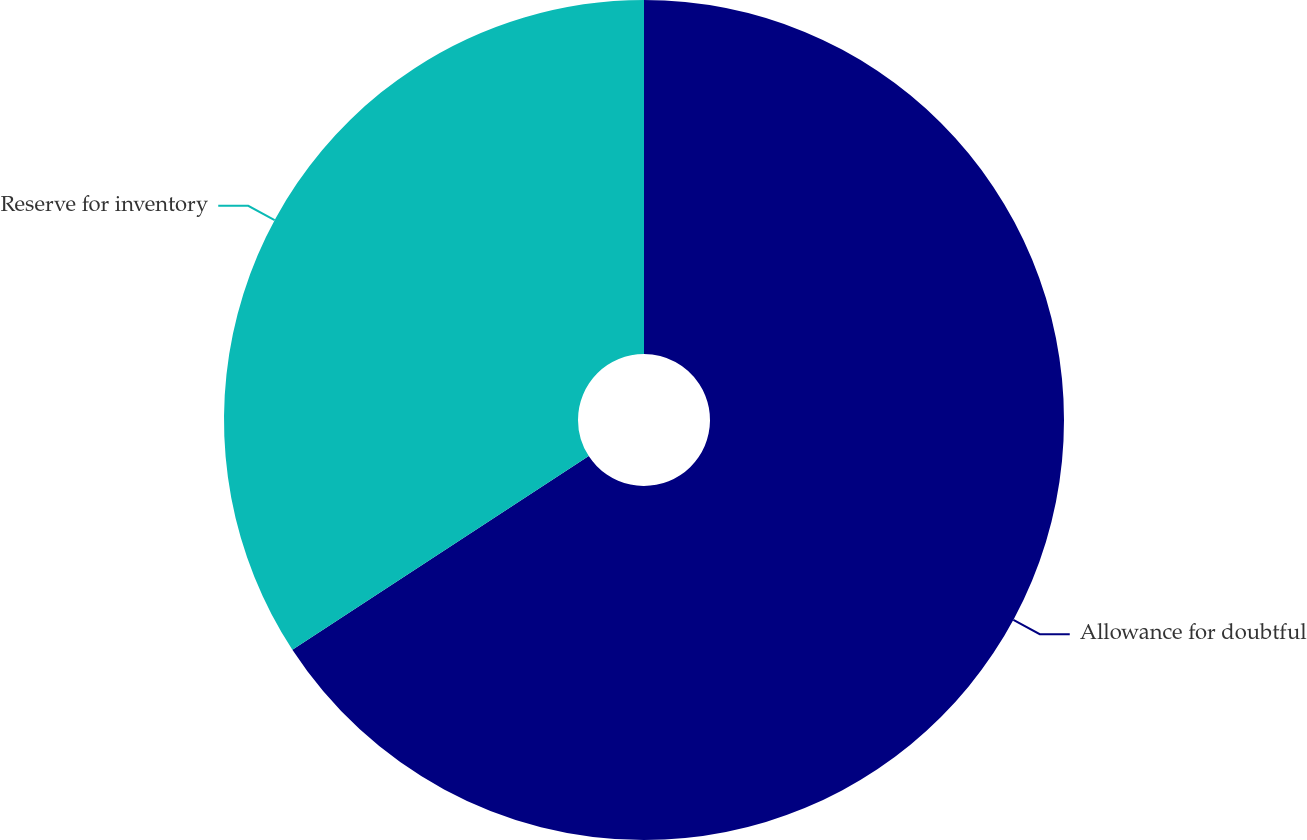Convert chart. <chart><loc_0><loc_0><loc_500><loc_500><pie_chart><fcel>Allowance for doubtful<fcel>Reserve for inventory<nl><fcel>65.79%<fcel>34.21%<nl></chart> 